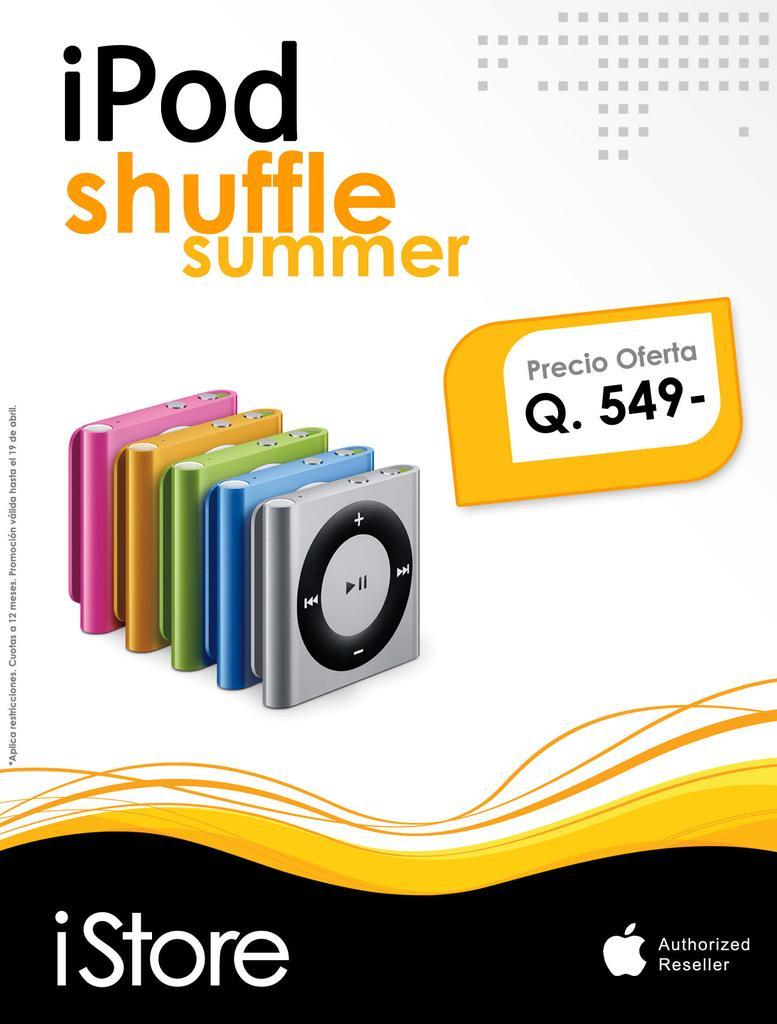Could you give a brief overview of what you see in this image? Here in this picture we can see a poster, on which we can see number of ipads and the price of it over there and we can see some text here and there. 